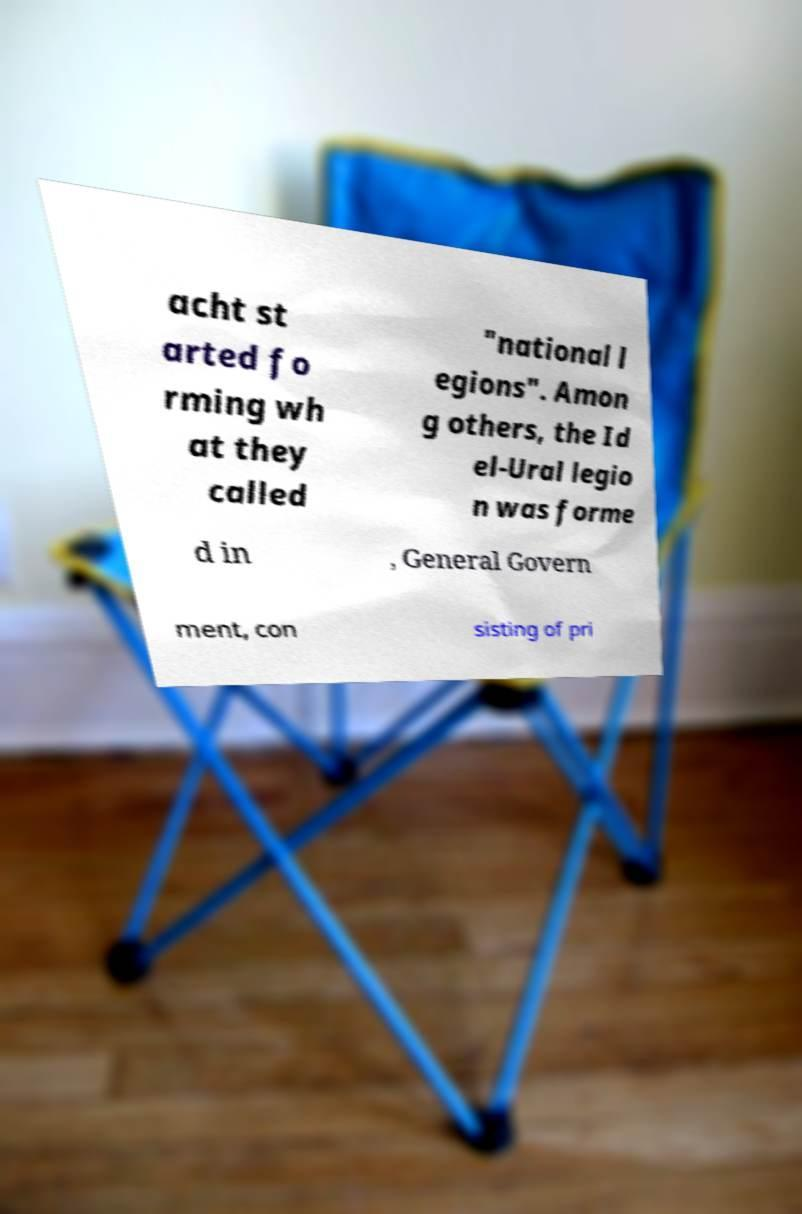There's text embedded in this image that I need extracted. Can you transcribe it verbatim? acht st arted fo rming wh at they called "national l egions". Amon g others, the Id el-Ural legio n was forme d in , General Govern ment, con sisting of pri 